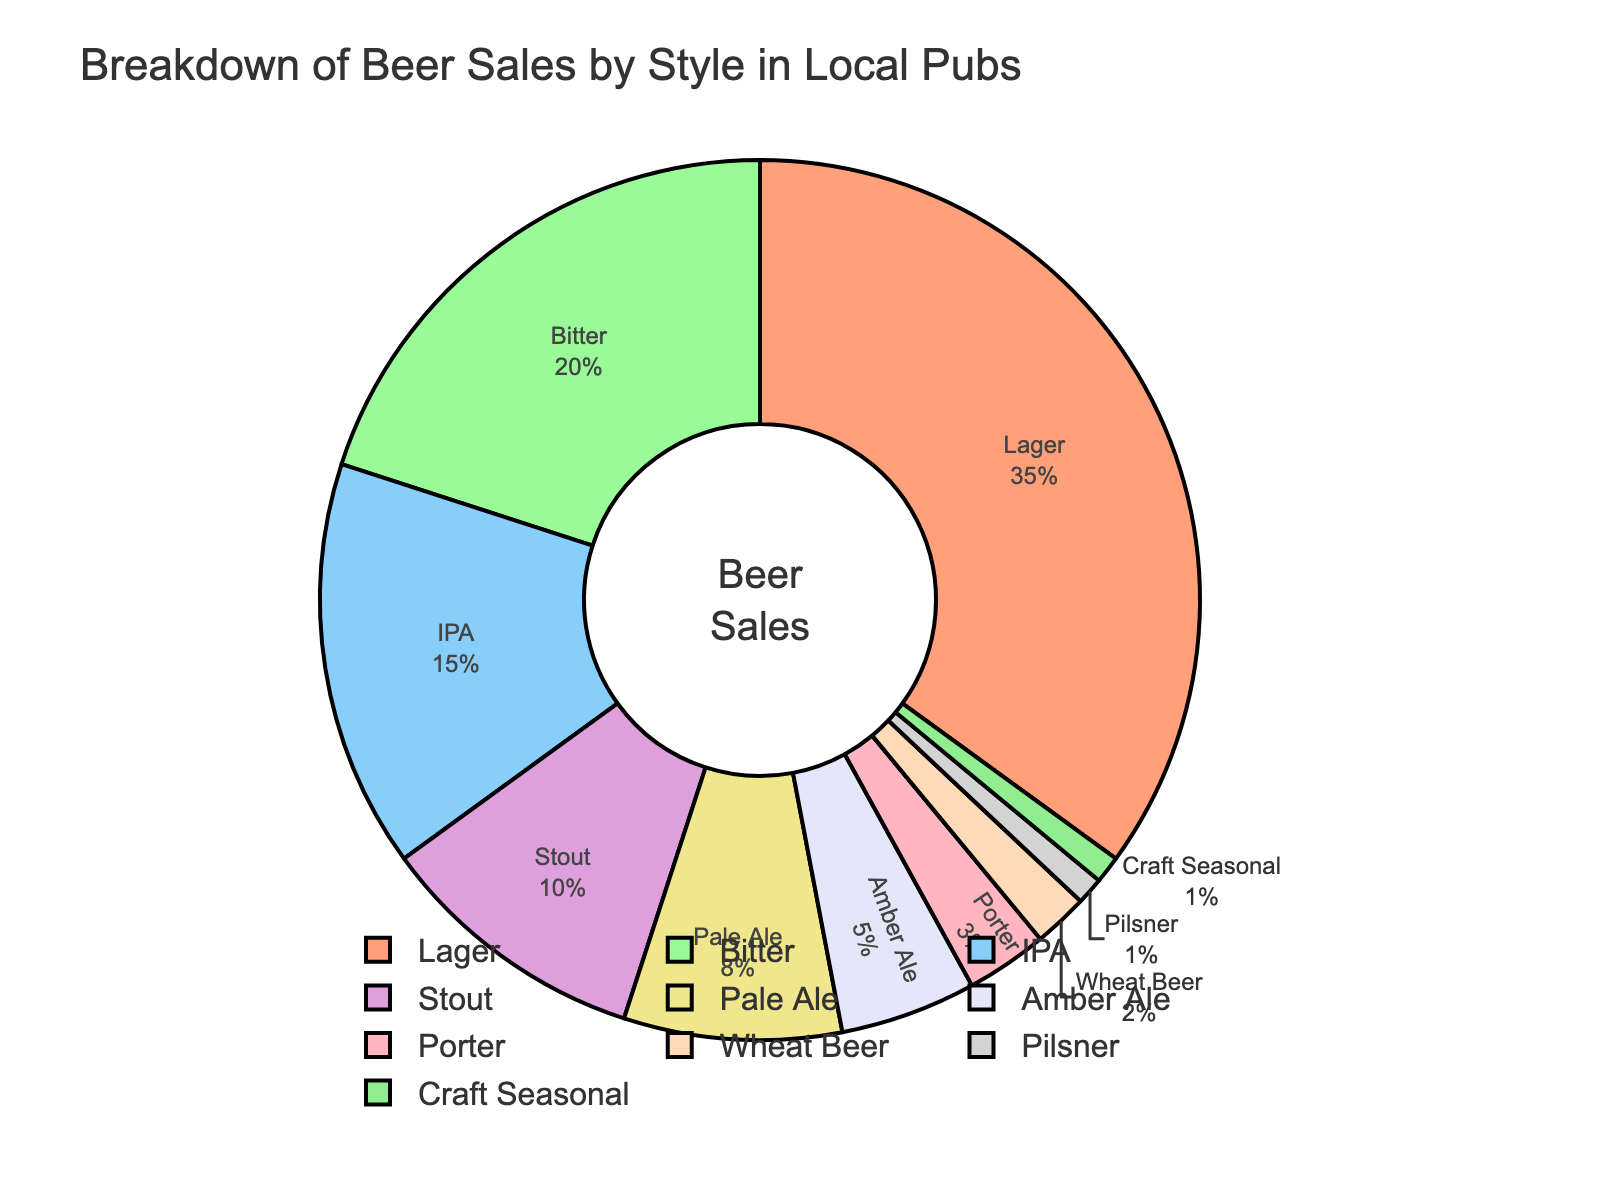What is the percentage of Lager sales? The Lager section is clearly labeled with its percentage on the chart.
Answer: 35% Which beer style has the second-highest sales? By looking at the labeled percentages, Bitter has the second-highest sales.
Answer: Bitter What is the combined percentage of IPA and Stout sales? Add the percentage of IPA (15%) and Stout (10%) together. 15% + 10% = 25%
Answer: 25% Is the percentage of Pale Ale sales greater than Amber Ale sales? By comparing the labeled percentages, Pale Ale (8%) is greater than Amber Ale (5%).
Answer: Yes Which beer style occupies the smallest section in the chart? The smallest sections would have the smallest labels; Craft Seasonal and Pilsner both have 1%, but Craft Seasonal appears last when listed.
Answer: Craft Seasonal What is the total percentage for all the beer styles that have less than 10% sales each? Sum Porter (3%), Wheat Beer (2%), Pilsner (1%), and Craft Seasonal (1%). 3% + 2% + 1% + 1% = 7%
Answer: 7% What is the difference in sales percentage between Lager and IPA? Subtract the percentage of IPA (15%) from the percentage of Lager (35%). 35% - 15% = 20%
Answer: 20% Which three beer styles combined equal 37% of the sales? Lager (35%) and Pilsner (1%) plus Craft Seasonal (1%) equal 37%.
Answer: Lager, Pilsner, Craft Seasonal How much greater is the sales percentage of Bitter compared to Porter? Subtract the percentage of Porter (3%) from the percentage of Bitter (20%). 20% - 3% = 17%
Answer: 17% Are there more sales from Stout or from Pale Ale and Amber Ale combined? Combine the sales percentages for Pale Ale (8%) and Amber Ale (5%) to get 13%. Since Stout is 10%, 13% is greater than 10%.
Answer: Pale Ale and Amber Ale combined 